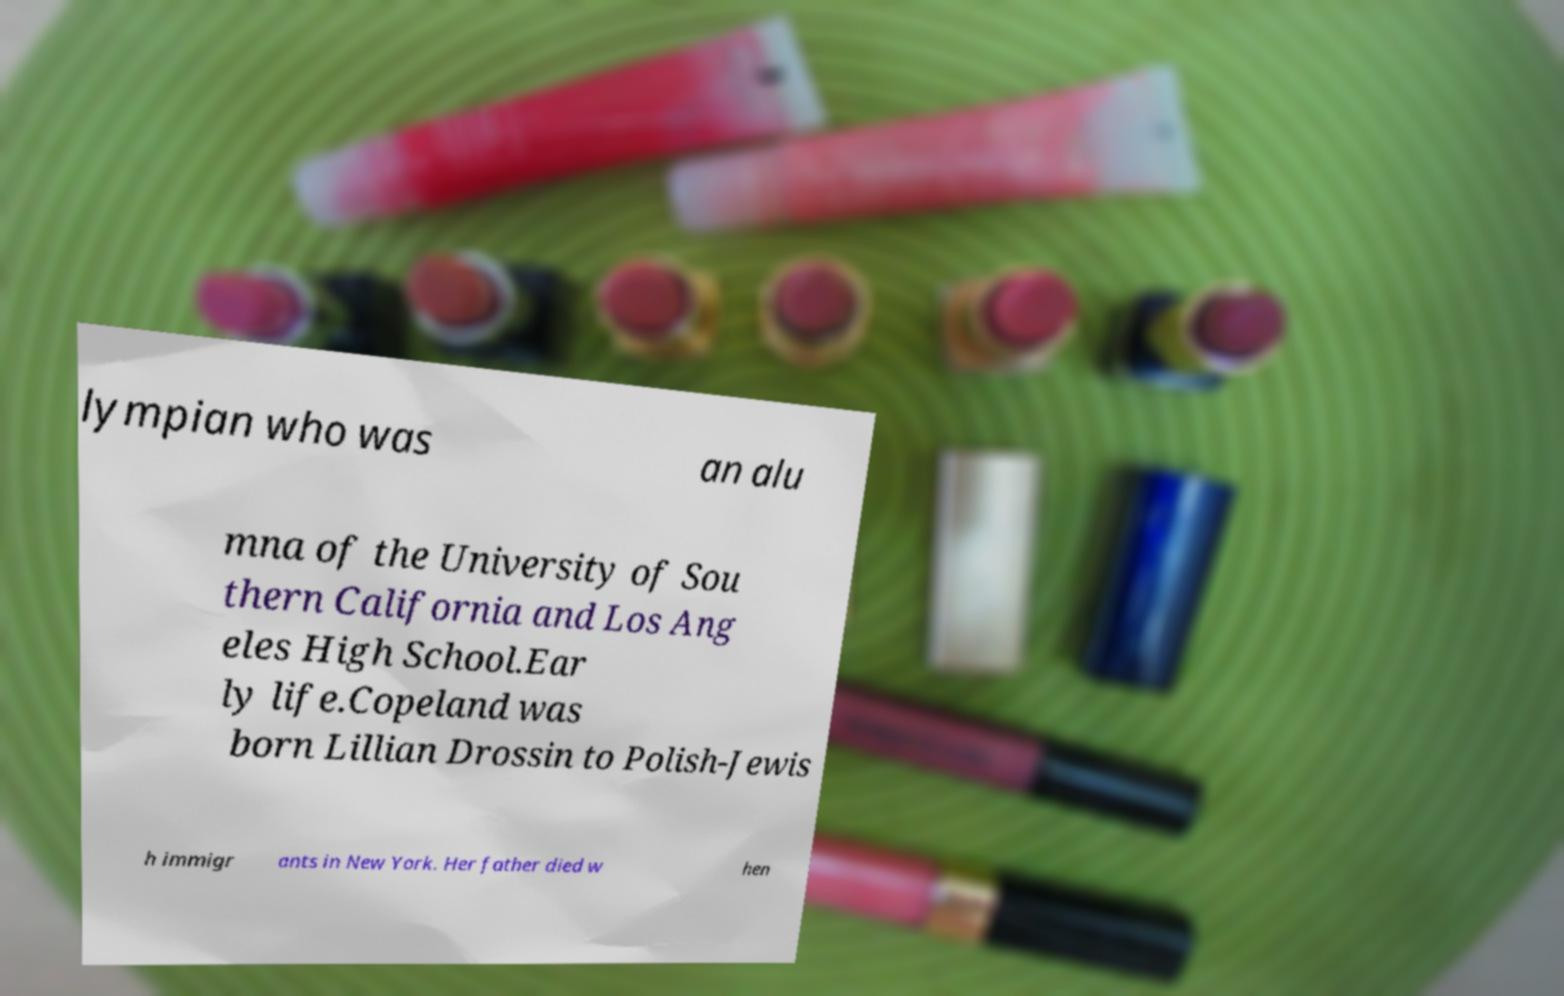I need the written content from this picture converted into text. Can you do that? lympian who was an alu mna of the University of Sou thern California and Los Ang eles High School.Ear ly life.Copeland was born Lillian Drossin to Polish-Jewis h immigr ants in New York. Her father died w hen 